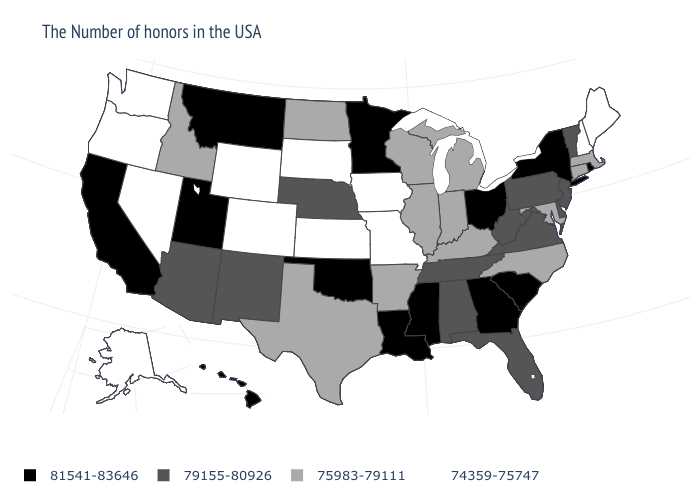Does Wisconsin have a lower value than Vermont?
Be succinct. Yes. Name the states that have a value in the range 79155-80926?
Concise answer only. Vermont, New Jersey, Delaware, Pennsylvania, Virginia, West Virginia, Florida, Alabama, Tennessee, Nebraska, New Mexico, Arizona. What is the value of Hawaii?
Give a very brief answer. 81541-83646. What is the value of Pennsylvania?
Short answer required. 79155-80926. What is the highest value in the South ?
Concise answer only. 81541-83646. What is the value of Massachusetts?
Be succinct. 75983-79111. What is the value of Kentucky?
Short answer required. 75983-79111. What is the highest value in the West ?
Give a very brief answer. 81541-83646. Name the states that have a value in the range 74359-75747?
Write a very short answer. Maine, New Hampshire, Missouri, Iowa, Kansas, South Dakota, Wyoming, Colorado, Nevada, Washington, Oregon, Alaska. Name the states that have a value in the range 75983-79111?
Write a very short answer. Massachusetts, Connecticut, Maryland, North Carolina, Michigan, Kentucky, Indiana, Wisconsin, Illinois, Arkansas, Texas, North Dakota, Idaho. Name the states that have a value in the range 79155-80926?
Keep it brief. Vermont, New Jersey, Delaware, Pennsylvania, Virginia, West Virginia, Florida, Alabama, Tennessee, Nebraska, New Mexico, Arizona. What is the value of Massachusetts?
Give a very brief answer. 75983-79111. Is the legend a continuous bar?
Answer briefly. No. Does New York have the highest value in the USA?
Concise answer only. Yes. 